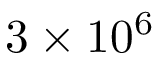<formula> <loc_0><loc_0><loc_500><loc_500>3 \times 1 0 ^ { 6 }</formula> 